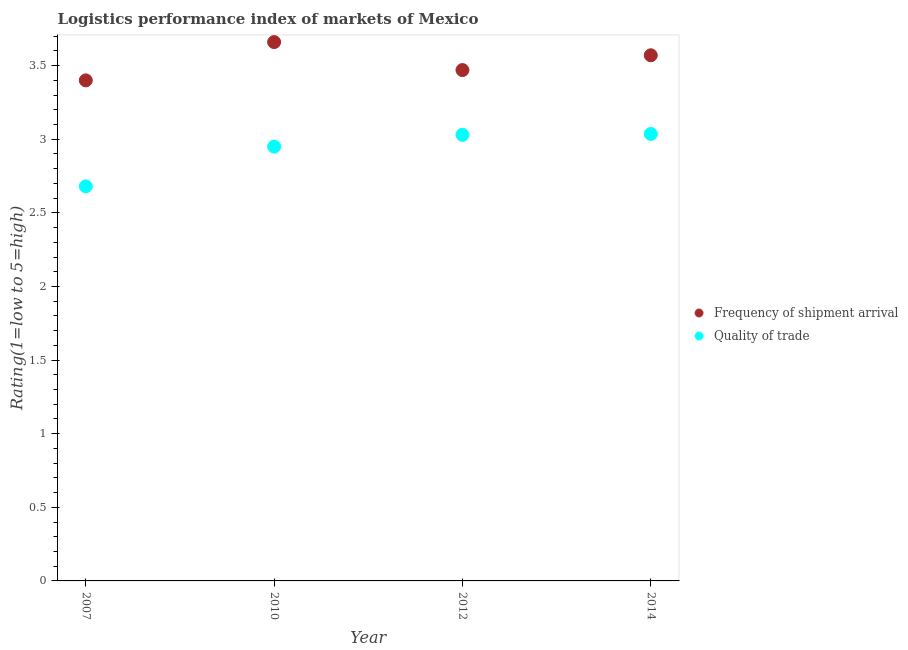How many different coloured dotlines are there?
Your answer should be very brief. 2. Is the number of dotlines equal to the number of legend labels?
Give a very brief answer. Yes. What is the lpi quality of trade in 2007?
Provide a short and direct response. 2.68. Across all years, what is the maximum lpi of frequency of shipment arrival?
Ensure brevity in your answer.  3.66. Across all years, what is the minimum lpi of frequency of shipment arrival?
Offer a terse response. 3.4. In which year was the lpi of frequency of shipment arrival minimum?
Keep it short and to the point. 2007. What is the total lpi quality of trade in the graph?
Your response must be concise. 11.7. What is the difference between the lpi quality of trade in 2007 and that in 2010?
Provide a short and direct response. -0.27. What is the difference between the lpi of frequency of shipment arrival in 2007 and the lpi quality of trade in 2010?
Provide a short and direct response. 0.45. What is the average lpi of frequency of shipment arrival per year?
Provide a short and direct response. 3.53. In the year 2007, what is the difference between the lpi quality of trade and lpi of frequency of shipment arrival?
Make the answer very short. -0.72. What is the ratio of the lpi quality of trade in 2007 to that in 2010?
Provide a succinct answer. 0.91. What is the difference between the highest and the second highest lpi quality of trade?
Offer a very short reply. 0.01. What is the difference between the highest and the lowest lpi quality of trade?
Your response must be concise. 0.36. Is the sum of the lpi quality of trade in 2010 and 2014 greater than the maximum lpi of frequency of shipment arrival across all years?
Provide a short and direct response. Yes. Is the lpi of frequency of shipment arrival strictly greater than the lpi quality of trade over the years?
Your response must be concise. Yes. How many dotlines are there?
Offer a very short reply. 2. Are the values on the major ticks of Y-axis written in scientific E-notation?
Provide a short and direct response. No. Does the graph contain grids?
Keep it short and to the point. No. Where does the legend appear in the graph?
Offer a very short reply. Center right. How many legend labels are there?
Keep it short and to the point. 2. What is the title of the graph?
Your answer should be very brief. Logistics performance index of markets of Mexico. What is the label or title of the Y-axis?
Your answer should be very brief. Rating(1=low to 5=high). What is the Rating(1=low to 5=high) of Quality of trade in 2007?
Make the answer very short. 2.68. What is the Rating(1=low to 5=high) in Frequency of shipment arrival in 2010?
Keep it short and to the point. 3.66. What is the Rating(1=low to 5=high) of Quality of trade in 2010?
Your response must be concise. 2.95. What is the Rating(1=low to 5=high) of Frequency of shipment arrival in 2012?
Your answer should be very brief. 3.47. What is the Rating(1=low to 5=high) of Quality of trade in 2012?
Make the answer very short. 3.03. What is the Rating(1=low to 5=high) in Frequency of shipment arrival in 2014?
Your response must be concise. 3.57. What is the Rating(1=low to 5=high) of Quality of trade in 2014?
Offer a very short reply. 3.04. Across all years, what is the maximum Rating(1=low to 5=high) in Frequency of shipment arrival?
Provide a succinct answer. 3.66. Across all years, what is the maximum Rating(1=low to 5=high) in Quality of trade?
Your response must be concise. 3.04. Across all years, what is the minimum Rating(1=low to 5=high) of Quality of trade?
Your response must be concise. 2.68. What is the total Rating(1=low to 5=high) in Frequency of shipment arrival in the graph?
Keep it short and to the point. 14.1. What is the total Rating(1=low to 5=high) in Quality of trade in the graph?
Make the answer very short. 11.7. What is the difference between the Rating(1=low to 5=high) in Frequency of shipment arrival in 2007 and that in 2010?
Ensure brevity in your answer.  -0.26. What is the difference between the Rating(1=low to 5=high) of Quality of trade in 2007 and that in 2010?
Give a very brief answer. -0.27. What is the difference between the Rating(1=low to 5=high) of Frequency of shipment arrival in 2007 and that in 2012?
Your answer should be very brief. -0.07. What is the difference between the Rating(1=low to 5=high) of Quality of trade in 2007 and that in 2012?
Your answer should be compact. -0.35. What is the difference between the Rating(1=low to 5=high) in Frequency of shipment arrival in 2007 and that in 2014?
Keep it short and to the point. -0.17. What is the difference between the Rating(1=low to 5=high) of Quality of trade in 2007 and that in 2014?
Provide a succinct answer. -0.36. What is the difference between the Rating(1=low to 5=high) of Frequency of shipment arrival in 2010 and that in 2012?
Provide a short and direct response. 0.19. What is the difference between the Rating(1=low to 5=high) of Quality of trade in 2010 and that in 2012?
Ensure brevity in your answer.  -0.08. What is the difference between the Rating(1=low to 5=high) of Frequency of shipment arrival in 2010 and that in 2014?
Ensure brevity in your answer.  0.09. What is the difference between the Rating(1=low to 5=high) in Quality of trade in 2010 and that in 2014?
Give a very brief answer. -0.09. What is the difference between the Rating(1=low to 5=high) in Frequency of shipment arrival in 2012 and that in 2014?
Your response must be concise. -0.1. What is the difference between the Rating(1=low to 5=high) of Quality of trade in 2012 and that in 2014?
Give a very brief answer. -0.01. What is the difference between the Rating(1=low to 5=high) of Frequency of shipment arrival in 2007 and the Rating(1=low to 5=high) of Quality of trade in 2010?
Provide a succinct answer. 0.45. What is the difference between the Rating(1=low to 5=high) of Frequency of shipment arrival in 2007 and the Rating(1=low to 5=high) of Quality of trade in 2012?
Offer a very short reply. 0.37. What is the difference between the Rating(1=low to 5=high) of Frequency of shipment arrival in 2007 and the Rating(1=low to 5=high) of Quality of trade in 2014?
Your answer should be compact. 0.36. What is the difference between the Rating(1=low to 5=high) in Frequency of shipment arrival in 2010 and the Rating(1=low to 5=high) in Quality of trade in 2012?
Offer a very short reply. 0.63. What is the difference between the Rating(1=low to 5=high) in Frequency of shipment arrival in 2010 and the Rating(1=low to 5=high) in Quality of trade in 2014?
Give a very brief answer. 0.62. What is the difference between the Rating(1=low to 5=high) of Frequency of shipment arrival in 2012 and the Rating(1=low to 5=high) of Quality of trade in 2014?
Give a very brief answer. 0.43. What is the average Rating(1=low to 5=high) of Frequency of shipment arrival per year?
Keep it short and to the point. 3.53. What is the average Rating(1=low to 5=high) of Quality of trade per year?
Provide a succinct answer. 2.92. In the year 2007, what is the difference between the Rating(1=low to 5=high) in Frequency of shipment arrival and Rating(1=low to 5=high) in Quality of trade?
Offer a very short reply. 0.72. In the year 2010, what is the difference between the Rating(1=low to 5=high) in Frequency of shipment arrival and Rating(1=low to 5=high) in Quality of trade?
Ensure brevity in your answer.  0.71. In the year 2012, what is the difference between the Rating(1=low to 5=high) in Frequency of shipment arrival and Rating(1=low to 5=high) in Quality of trade?
Keep it short and to the point. 0.44. In the year 2014, what is the difference between the Rating(1=low to 5=high) in Frequency of shipment arrival and Rating(1=low to 5=high) in Quality of trade?
Give a very brief answer. 0.53. What is the ratio of the Rating(1=low to 5=high) of Frequency of shipment arrival in 2007 to that in 2010?
Provide a succinct answer. 0.93. What is the ratio of the Rating(1=low to 5=high) of Quality of trade in 2007 to that in 2010?
Your response must be concise. 0.91. What is the ratio of the Rating(1=low to 5=high) in Frequency of shipment arrival in 2007 to that in 2012?
Keep it short and to the point. 0.98. What is the ratio of the Rating(1=low to 5=high) of Quality of trade in 2007 to that in 2012?
Provide a succinct answer. 0.88. What is the ratio of the Rating(1=low to 5=high) of Frequency of shipment arrival in 2007 to that in 2014?
Your response must be concise. 0.95. What is the ratio of the Rating(1=low to 5=high) in Quality of trade in 2007 to that in 2014?
Provide a succinct answer. 0.88. What is the ratio of the Rating(1=low to 5=high) of Frequency of shipment arrival in 2010 to that in 2012?
Provide a short and direct response. 1.05. What is the ratio of the Rating(1=low to 5=high) in Quality of trade in 2010 to that in 2012?
Your response must be concise. 0.97. What is the ratio of the Rating(1=low to 5=high) in Frequency of shipment arrival in 2010 to that in 2014?
Keep it short and to the point. 1.03. What is the ratio of the Rating(1=low to 5=high) in Quality of trade in 2010 to that in 2014?
Your response must be concise. 0.97. What is the ratio of the Rating(1=low to 5=high) of Frequency of shipment arrival in 2012 to that in 2014?
Offer a very short reply. 0.97. What is the difference between the highest and the second highest Rating(1=low to 5=high) of Frequency of shipment arrival?
Your answer should be compact. 0.09. What is the difference between the highest and the second highest Rating(1=low to 5=high) in Quality of trade?
Provide a short and direct response. 0.01. What is the difference between the highest and the lowest Rating(1=low to 5=high) in Frequency of shipment arrival?
Keep it short and to the point. 0.26. What is the difference between the highest and the lowest Rating(1=low to 5=high) in Quality of trade?
Your answer should be very brief. 0.36. 